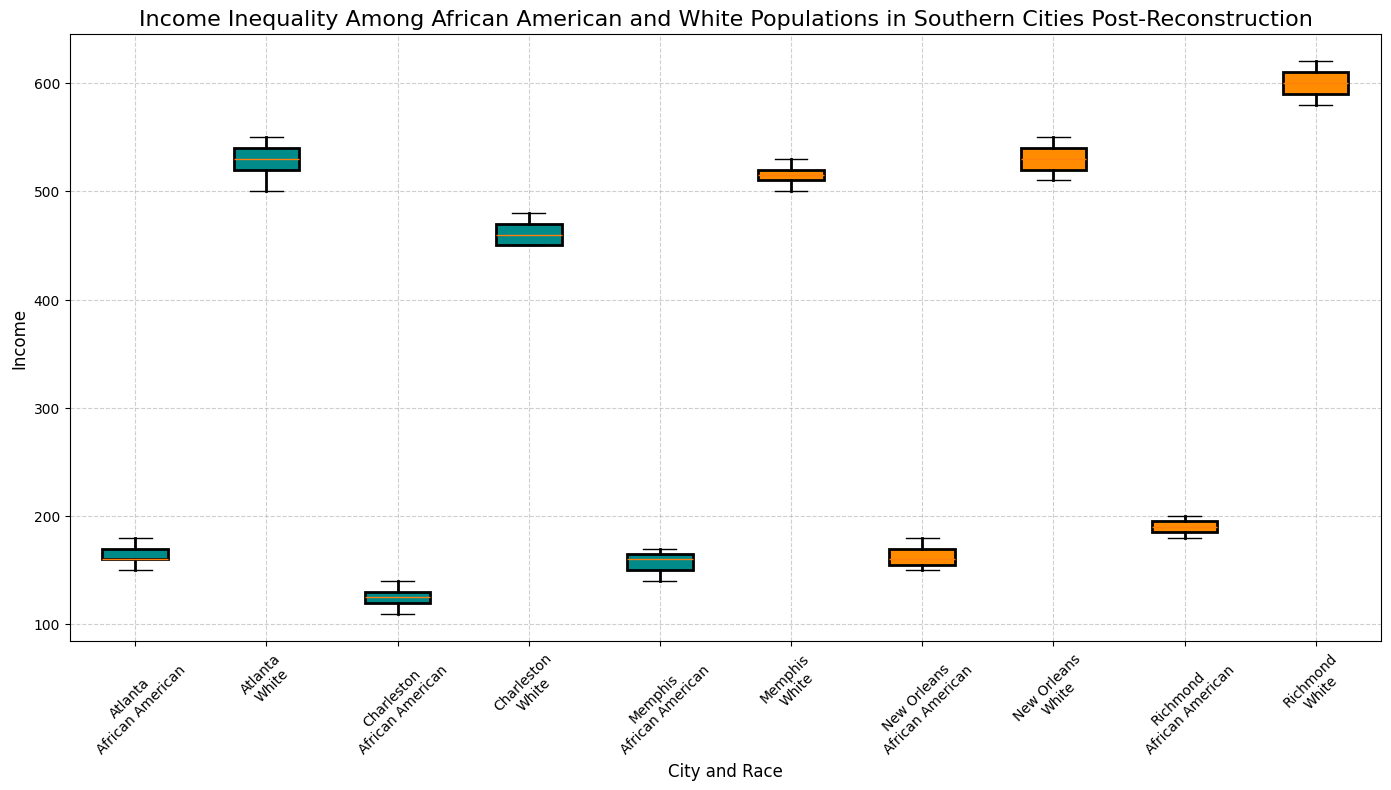What's the median income for the African American population in Atlanta? In the box plot, the median is represented by the line inside the box for each group. For the African American population in Atlanta, locate the line inside the box corresponding to Atlanta (African American).
Answer: 160 Which city has the highest median income for the White population? Look for the highest line inside the boxes of the groups representing the White population in each city. For Richmond (White), the median line is at the highest point compared to other cities.
Answer: Richmond What is the range of incomes for the African American population in Charleston? The range is the difference between the maximum and minimum values. The whiskers of the box plot for Charleston (African American) stretch from 110 to 140, indicating the range.
Answer: 30 Which city shows the greatest income inequality between African American and White populations, based on the difference in median incomes? Calculate the difference between the median incomes for the African American and White populations for each city. Atlanta has the largest difference.
Answer: Atlanta What's the interquartile range (IQR) for the White population in Memphis? The IQR is the difference between the 75th percentile (top of the box) and the 25th percentile (bottom of the box). For Memphis (White), these values can be read from the box plot.
Answer: 15 In which city do African Americans have the lowest median income? Find the box corresponding to the African American population in each city, and identify the lowest median line. For Charleston, the median income is the lowest.
Answer: Charleston Compare the median incomes of African Americans in Richmond and New Orleans. Which city has a higher median income? Locate the median lines inside the boxes for the African American populations in both Richmond and New Orleans. The median line is higher for Richmond.
Answer: Richmond How does the income distribution for the White population in New Orleans compare to that in Atlanta? Compare the spread (range), the interquartile range (IQR), and the median positions of the two box plots representing the White populations in New Orleans and Atlanta. Generally, distributions appear wider in Atlanta.
Answer: New Orleans has a narrower distribution Which city's African American population has the highest maximum income? Identify the extent of the upper whisker for African American populations across all cities. For Richmond, the upper whisker extends the highest.
Answer: Richmond What can we infer about income disparity if the boxes for African American and White populations in the same city have largely overlapping ranges? If the boxes overlap significantly, this indicates less disparity in income distribution between the two populations.
Answer: Less disparity 